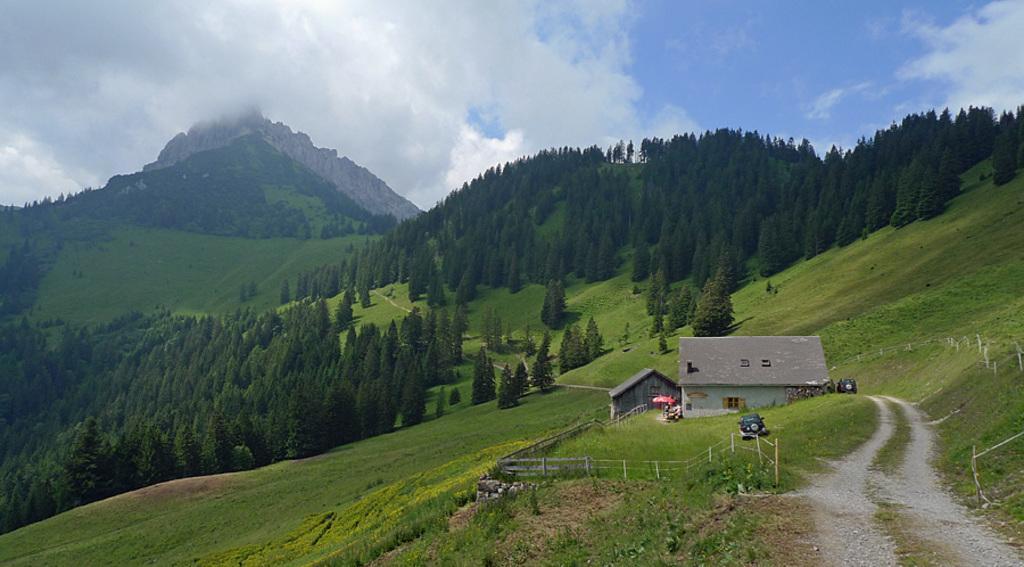How would you summarize this image in a sentence or two? In this picture we can see there are houses, vehicles, grass and the fencing. Behind the houses, there are trees and hills. In the bottom right corner of the image, there is a path and a stick. At the top of the image, there is the cloudy sky. 